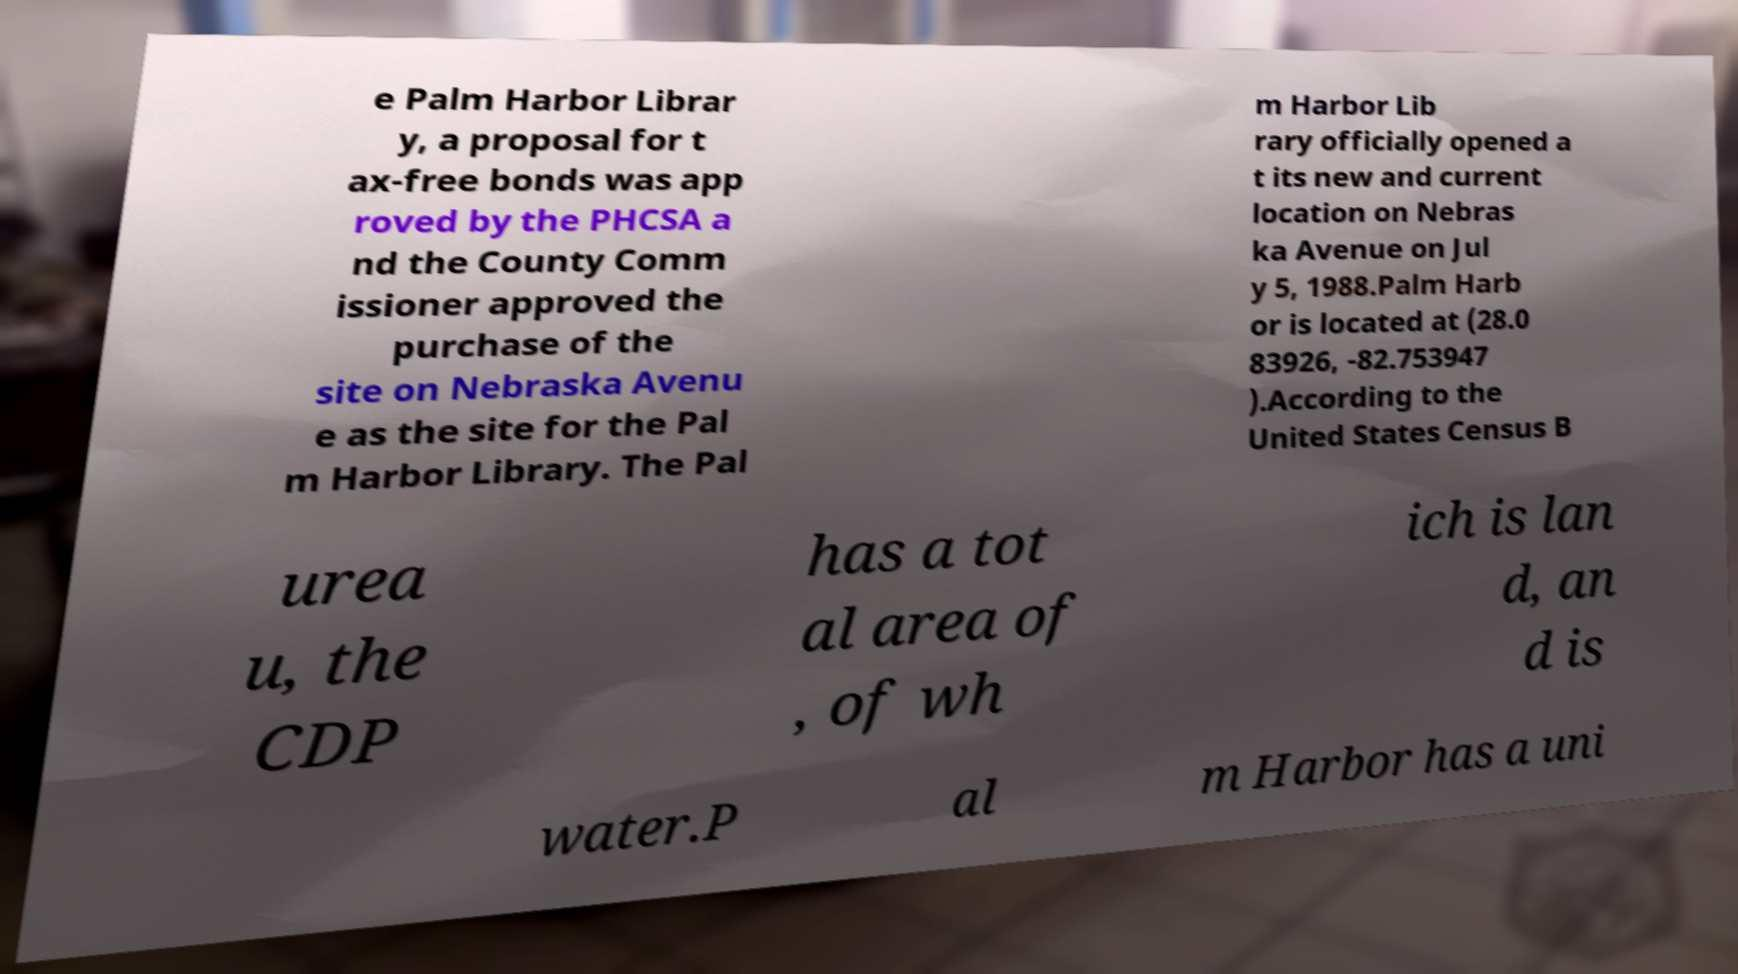There's text embedded in this image that I need extracted. Can you transcribe it verbatim? e Palm Harbor Librar y, a proposal for t ax-free bonds was app roved by the PHCSA a nd the County Comm issioner approved the purchase of the site on Nebraska Avenu e as the site for the Pal m Harbor Library. The Pal m Harbor Lib rary officially opened a t its new and current location on Nebras ka Avenue on Jul y 5, 1988.Palm Harb or is located at (28.0 83926, -82.753947 ).According to the United States Census B urea u, the CDP has a tot al area of , of wh ich is lan d, an d is water.P al m Harbor has a uni 